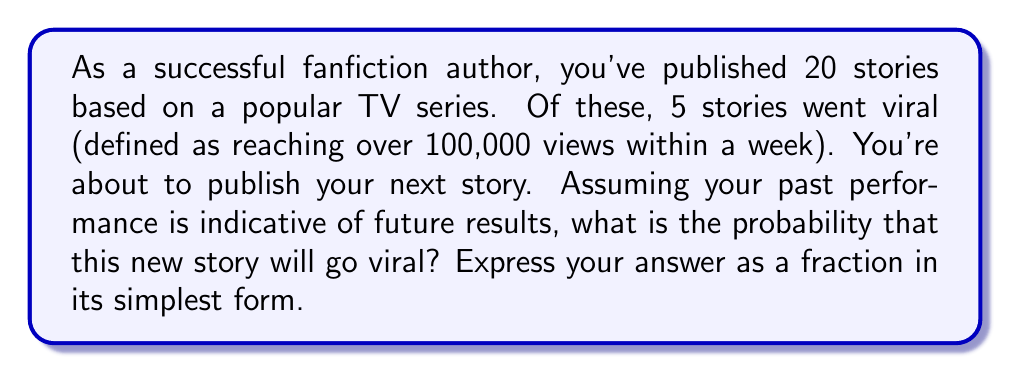Give your solution to this math problem. Let's approach this step-by-step using basic probability theory:

1) First, we need to identify the probability of a story going viral based on past performance.

2) We're given that:
   - Total number of stories published = 20
   - Number of stories that went viral = 5

3) The probability of an event is calculated by:

   $$P(\text{event}) = \frac{\text{number of favorable outcomes}}{\text{total number of possible outcomes}}$$

4) In this case:
   
   $$P(\text{story goes viral}) = \frac{\text{number of viral stories}}{\text{total number of stories}} = \frac{5}{20}$$

5) To simplify this fraction, we can divide both numerator and denominator by their greatest common divisor (GCD).
   The GCD of 5 and 20 is 5.

   $$\frac{5 \div 5}{20 \div 5} = \frac{1}{4}$$

6) Therefore, based on past performance, the probability of any given story going viral is $\frac{1}{4}$.

7) Assuming that this probability applies to the new story as well, the probability of the new story going viral is also $\frac{1}{4}$.
Answer: $\frac{1}{4}$ 